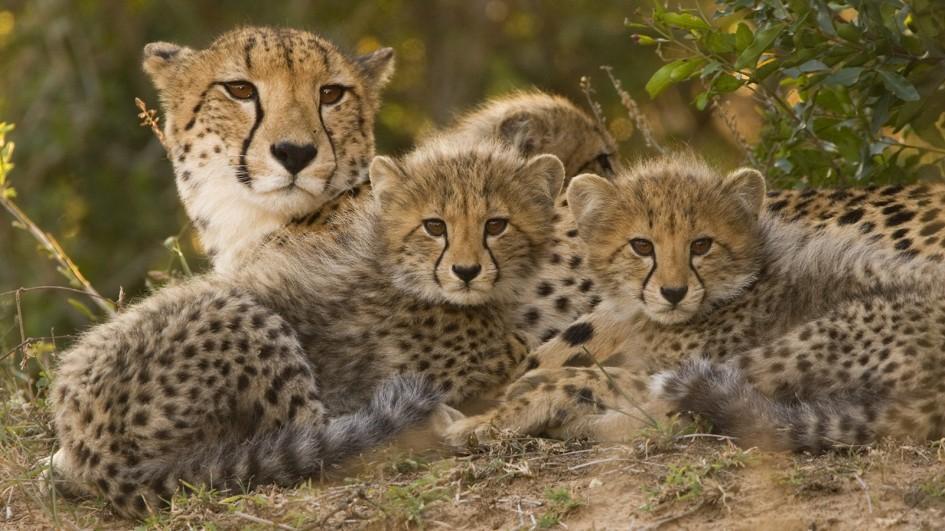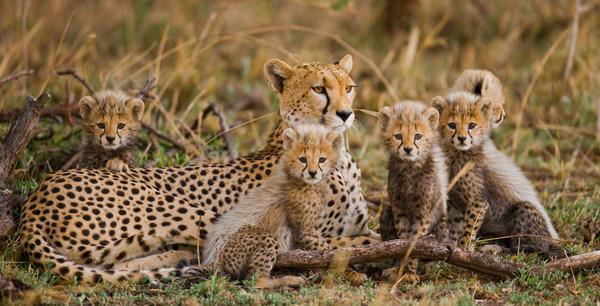The first image is the image on the left, the second image is the image on the right. Examine the images to the left and right. Is the description "The left image contains more cheetahs than the right image." accurate? Answer yes or no. No. The first image is the image on the left, the second image is the image on the right. For the images shown, is this caption "There are five animals in the image on the right." true? Answer yes or no. Yes. 